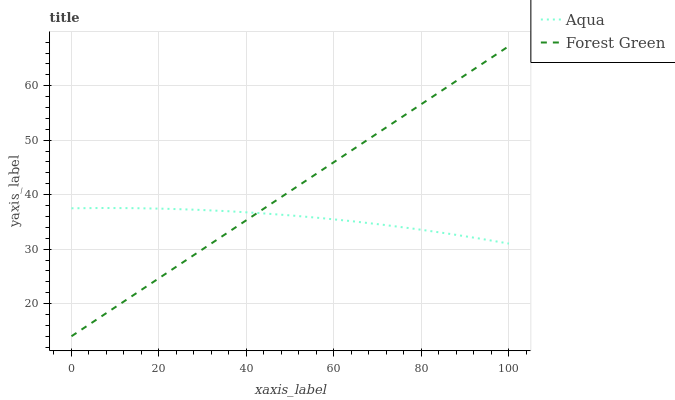Does Aqua have the minimum area under the curve?
Answer yes or no. Yes. Does Forest Green have the maximum area under the curve?
Answer yes or no. Yes. Does Aqua have the maximum area under the curve?
Answer yes or no. No. Is Forest Green the smoothest?
Answer yes or no. Yes. Is Aqua the roughest?
Answer yes or no. Yes. Is Aqua the smoothest?
Answer yes or no. No. Does Forest Green have the lowest value?
Answer yes or no. Yes. Does Aqua have the lowest value?
Answer yes or no. No. Does Forest Green have the highest value?
Answer yes or no. Yes. Does Aqua have the highest value?
Answer yes or no. No. Does Forest Green intersect Aqua?
Answer yes or no. Yes. Is Forest Green less than Aqua?
Answer yes or no. No. Is Forest Green greater than Aqua?
Answer yes or no. No. 